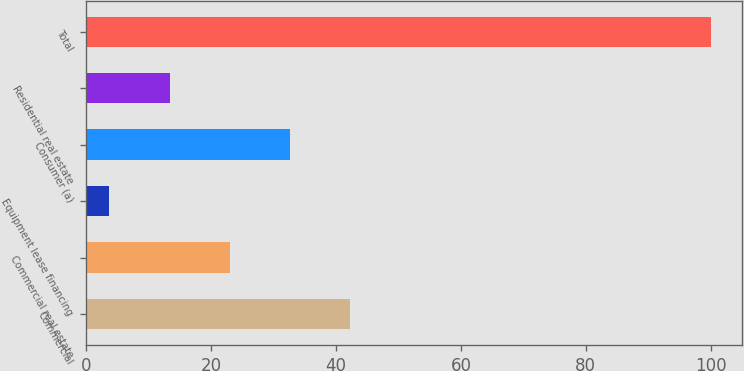Convert chart. <chart><loc_0><loc_0><loc_500><loc_500><bar_chart><fcel>Commercial<fcel>Commercial real estate<fcel>Equipment lease financing<fcel>Consumer (a)<fcel>Residential real estate<fcel>Total<nl><fcel>42.22<fcel>22.96<fcel>3.7<fcel>32.59<fcel>13.33<fcel>100<nl></chart> 